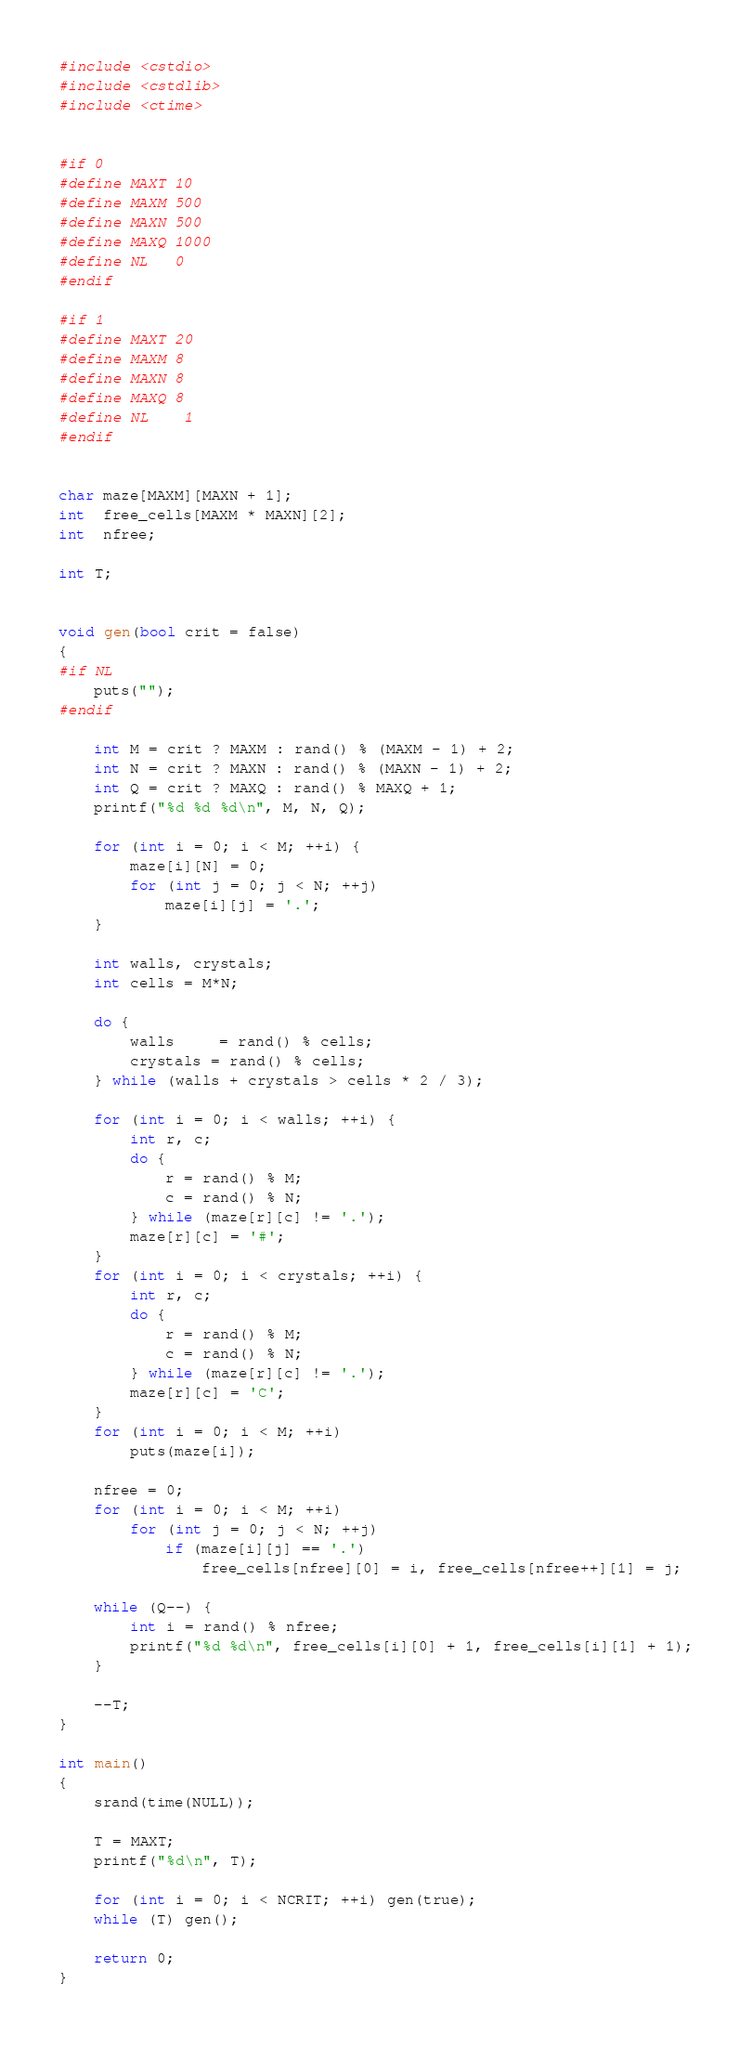Convert code to text. <code><loc_0><loc_0><loc_500><loc_500><_C++_>#include <cstdio>
#include <cstdlib>
#include <ctime>


#if 0
#define MAXT 10
#define MAXM 500
#define MAXN 500
#define MAXQ 1000
#define NL	 0
#endif

#if 1
#define MAXT 20
#define MAXM 8
#define MAXN 8
#define MAXQ 8
#define NL	 1
#endif


char maze[MAXM][MAXN + 1];
int  free_cells[MAXM * MAXN][2];
int  nfree;

int T;


void gen(bool crit = false)
{
#if NL
	puts("");
#endif

	int M = crit ? MAXM : rand() % (MAXM - 1) + 2;
	int N = crit ? MAXN : rand() % (MAXN - 1) + 2;
	int Q = crit ? MAXQ : rand() % MAXQ + 1;
	printf("%d %d %d\n", M, N, Q);

	for (int i = 0; i < M; ++i) {
		maze[i][N] = 0;
		for (int j = 0; j < N; ++j)
			maze[i][j] = '.';
	}

	int walls, crystals;
	int cells = M*N;

	do {
		walls	 = rand() % cells;
		crystals = rand() % cells;
	} while (walls + crystals > cells * 2 / 3);

	for (int i = 0; i < walls; ++i) {
		int r, c;
		do {
			r = rand() % M;
			c = rand() % N;
		} while (maze[r][c] != '.');
		maze[r][c] = '#';
	}
	for (int i = 0; i < crystals; ++i) {
		int r, c;
		do {
			r = rand() % M;
			c = rand() % N;
		} while (maze[r][c] != '.');
		maze[r][c] = 'C';
	}
	for (int i = 0; i < M; ++i)
		puts(maze[i]);

	nfree = 0;
	for (int i = 0; i < M; ++i)
		for (int j = 0; j < N; ++j)
			if (maze[i][j] == '.')
				free_cells[nfree][0] = i, free_cells[nfree++][1] = j;

	while (Q--) {
		int i = rand() % nfree;
		printf("%d %d\n", free_cells[i][0] + 1, free_cells[i][1] + 1);
	}

	--T;
}

int main()
{
	srand(time(NULL));

	T = MAXT;
	printf("%d\n", T);

	for (int i = 0; i < NCRIT; ++i) gen(true);
	while (T) gen();

	return 0;
}
</code> 